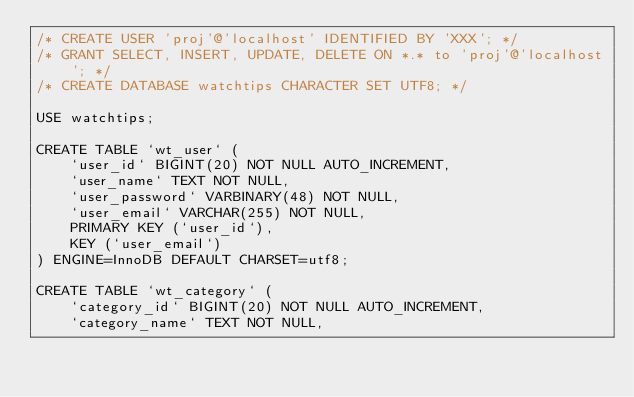<code> <loc_0><loc_0><loc_500><loc_500><_SQL_>/* CREATE USER 'proj'@'localhost' IDENTIFIED BY 'XXX'; */
/* GRANT SELECT, INSERT, UPDATE, DELETE ON *.* to 'proj'@'localhost'; */
/* CREATE DATABASE watchtips CHARACTER SET UTF8; */

USE watchtips;

CREATE TABLE `wt_user` (
    `user_id` BIGINT(20) NOT NULL AUTO_INCREMENT,
    `user_name` TEXT NOT NULL,
    `user_password` VARBINARY(48) NOT NULL,
    `user_email` VARCHAR(255) NOT NULL,
    PRIMARY KEY (`user_id`),
    KEY (`user_email`)
) ENGINE=InnoDB DEFAULT CHARSET=utf8;

CREATE TABLE `wt_category` (
    `category_id` BIGINT(20) NOT NULL AUTO_INCREMENT,
    `category_name` TEXT NOT NULL,</code> 